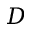<formula> <loc_0><loc_0><loc_500><loc_500>D</formula> 